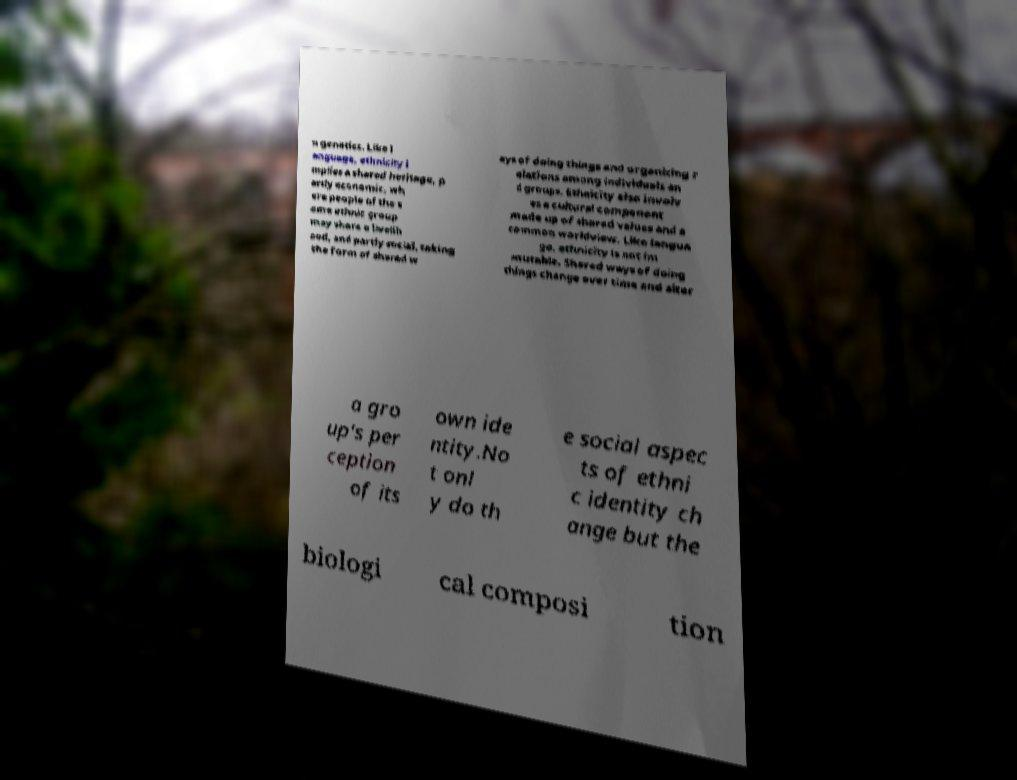Can you read and provide the text displayed in the image?This photo seems to have some interesting text. Can you extract and type it out for me? n genetics. Like l anguage, ethnicity i mplies a shared heritage, p artly economic, wh ere people of the s ame ethnic group may share a livelih ood, and partly social, taking the form of shared w ays of doing things and organizing r elations among individuals an d groups. Ethnicity also involv es a cultural component made up of shared values and a common worldview. Like langua ge, ethnicity is not im mutable. Shared ways of doing things change over time and alter a gro up's per ception of its own ide ntity.No t onl y do th e social aspec ts of ethni c identity ch ange but the biologi cal composi tion 